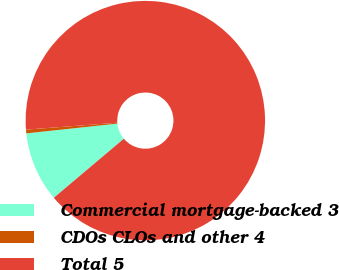<chart> <loc_0><loc_0><loc_500><loc_500><pie_chart><fcel>Commercial mortgage-backed 3<fcel>CDOs CLOs and other 4<fcel>Total 5<nl><fcel>9.45%<fcel>0.5%<fcel>90.05%<nl></chart> 